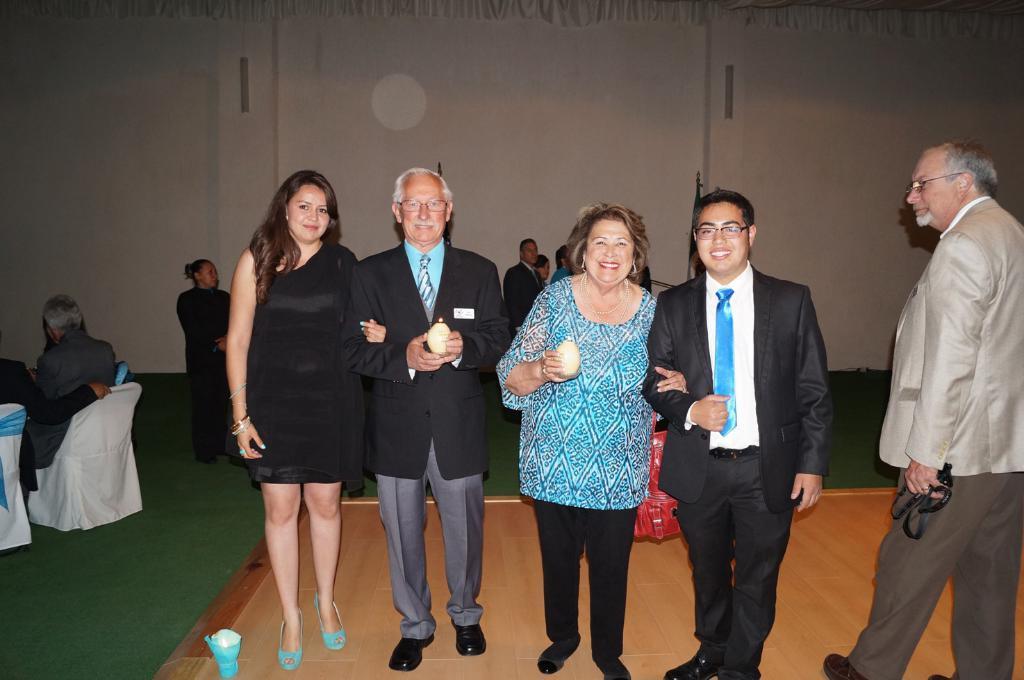In one or two sentences, can you explain what this image depicts? In the center of the image there are people standing. At the left side of the image there are people sitting on chairs. In the background of the image there is wall. 